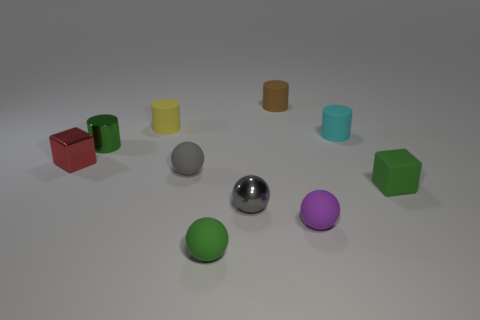Subtract 1 spheres. How many spheres are left? 3 Subtract all cylinders. How many objects are left? 6 Add 2 red blocks. How many red blocks exist? 3 Subtract 1 red blocks. How many objects are left? 9 Subtract all tiny matte cubes. Subtract all small green cylinders. How many objects are left? 8 Add 3 tiny green objects. How many tiny green objects are left? 6 